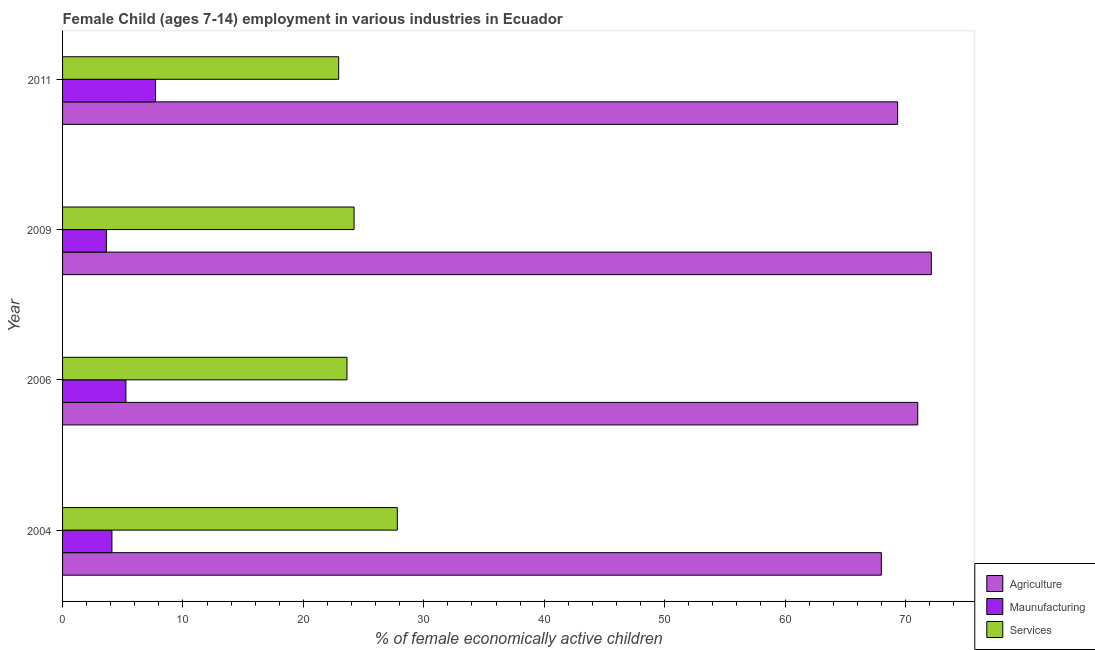How many groups of bars are there?
Provide a succinct answer. 4. Are the number of bars on each tick of the Y-axis equal?
Keep it short and to the point. Yes. How many bars are there on the 4th tick from the bottom?
Make the answer very short. 3. What is the label of the 1st group of bars from the top?
Provide a short and direct response. 2011. What is the percentage of economically active children in services in 2009?
Provide a short and direct response. 24.21. Across all years, what is the maximum percentage of economically active children in services?
Provide a short and direct response. 27.8. Across all years, what is the minimum percentage of economically active children in agriculture?
Keep it short and to the point. 68. What is the total percentage of economically active children in services in the graph?
Your answer should be compact. 98.56. What is the difference between the percentage of economically active children in manufacturing in 2006 and that in 2011?
Ensure brevity in your answer.  -2.46. What is the difference between the percentage of economically active children in services in 2006 and the percentage of economically active children in agriculture in 2011?
Offer a very short reply. -45.73. What is the average percentage of economically active children in agriculture per year?
Your response must be concise. 70.13. In the year 2006, what is the difference between the percentage of economically active children in agriculture and percentage of economically active children in manufacturing?
Provide a short and direct response. 65.76. What is the ratio of the percentage of economically active children in manufacturing in 2006 to that in 2009?
Ensure brevity in your answer.  1.45. Is the percentage of economically active children in services in 2006 less than that in 2011?
Offer a terse response. No. Is the difference between the percentage of economically active children in services in 2006 and 2011 greater than the difference between the percentage of economically active children in manufacturing in 2006 and 2011?
Your answer should be compact. Yes. What is the difference between the highest and the second highest percentage of economically active children in manufacturing?
Your response must be concise. 2.46. What is the difference between the highest and the lowest percentage of economically active children in manufacturing?
Provide a succinct answer. 4.08. Is the sum of the percentage of economically active children in services in 2006 and 2011 greater than the maximum percentage of economically active children in agriculture across all years?
Provide a short and direct response. No. What does the 1st bar from the top in 2004 represents?
Provide a succinct answer. Services. What does the 3rd bar from the bottom in 2004 represents?
Make the answer very short. Services. How many bars are there?
Give a very brief answer. 12. How many years are there in the graph?
Your answer should be very brief. 4. What is the difference between two consecutive major ticks on the X-axis?
Keep it short and to the point. 10. Does the graph contain any zero values?
Make the answer very short. No. Where does the legend appear in the graph?
Provide a short and direct response. Bottom right. What is the title of the graph?
Offer a very short reply. Female Child (ages 7-14) employment in various industries in Ecuador. What is the label or title of the X-axis?
Make the answer very short. % of female economically active children. What is the % of female economically active children of Agriculture in 2004?
Give a very brief answer. 68. What is the % of female economically active children of Maunufacturing in 2004?
Your answer should be very brief. 4.1. What is the % of female economically active children of Services in 2004?
Make the answer very short. 27.8. What is the % of female economically active children in Agriculture in 2006?
Ensure brevity in your answer.  71.02. What is the % of female economically active children in Maunufacturing in 2006?
Offer a terse response. 5.26. What is the % of female economically active children in Services in 2006?
Ensure brevity in your answer.  23.62. What is the % of female economically active children in Agriculture in 2009?
Provide a short and direct response. 72.15. What is the % of female economically active children of Maunufacturing in 2009?
Provide a short and direct response. 3.64. What is the % of female economically active children of Services in 2009?
Give a very brief answer. 24.21. What is the % of female economically active children of Agriculture in 2011?
Ensure brevity in your answer.  69.35. What is the % of female economically active children of Maunufacturing in 2011?
Offer a very short reply. 7.72. What is the % of female economically active children in Services in 2011?
Give a very brief answer. 22.93. Across all years, what is the maximum % of female economically active children in Agriculture?
Give a very brief answer. 72.15. Across all years, what is the maximum % of female economically active children of Maunufacturing?
Ensure brevity in your answer.  7.72. Across all years, what is the maximum % of female economically active children of Services?
Ensure brevity in your answer.  27.8. Across all years, what is the minimum % of female economically active children in Maunufacturing?
Give a very brief answer. 3.64. Across all years, what is the minimum % of female economically active children in Services?
Your answer should be compact. 22.93. What is the total % of female economically active children of Agriculture in the graph?
Keep it short and to the point. 280.52. What is the total % of female economically active children of Maunufacturing in the graph?
Provide a short and direct response. 20.72. What is the total % of female economically active children in Services in the graph?
Offer a very short reply. 98.56. What is the difference between the % of female economically active children in Agriculture in 2004 and that in 2006?
Offer a very short reply. -3.02. What is the difference between the % of female economically active children of Maunufacturing in 2004 and that in 2006?
Ensure brevity in your answer.  -1.16. What is the difference between the % of female economically active children of Services in 2004 and that in 2006?
Your answer should be very brief. 4.18. What is the difference between the % of female economically active children in Agriculture in 2004 and that in 2009?
Your response must be concise. -4.15. What is the difference between the % of female economically active children of Maunufacturing in 2004 and that in 2009?
Your response must be concise. 0.46. What is the difference between the % of female economically active children in Services in 2004 and that in 2009?
Offer a terse response. 3.59. What is the difference between the % of female economically active children of Agriculture in 2004 and that in 2011?
Keep it short and to the point. -1.35. What is the difference between the % of female economically active children in Maunufacturing in 2004 and that in 2011?
Offer a terse response. -3.62. What is the difference between the % of female economically active children in Services in 2004 and that in 2011?
Offer a very short reply. 4.87. What is the difference between the % of female economically active children in Agriculture in 2006 and that in 2009?
Your response must be concise. -1.13. What is the difference between the % of female economically active children in Maunufacturing in 2006 and that in 2009?
Offer a terse response. 1.62. What is the difference between the % of female economically active children of Services in 2006 and that in 2009?
Offer a terse response. -0.59. What is the difference between the % of female economically active children of Agriculture in 2006 and that in 2011?
Ensure brevity in your answer.  1.67. What is the difference between the % of female economically active children of Maunufacturing in 2006 and that in 2011?
Offer a very short reply. -2.46. What is the difference between the % of female economically active children in Services in 2006 and that in 2011?
Give a very brief answer. 0.69. What is the difference between the % of female economically active children of Agriculture in 2009 and that in 2011?
Your answer should be very brief. 2.8. What is the difference between the % of female economically active children in Maunufacturing in 2009 and that in 2011?
Give a very brief answer. -4.08. What is the difference between the % of female economically active children in Services in 2009 and that in 2011?
Your answer should be compact. 1.28. What is the difference between the % of female economically active children in Agriculture in 2004 and the % of female economically active children in Maunufacturing in 2006?
Keep it short and to the point. 62.74. What is the difference between the % of female economically active children in Agriculture in 2004 and the % of female economically active children in Services in 2006?
Offer a terse response. 44.38. What is the difference between the % of female economically active children of Maunufacturing in 2004 and the % of female economically active children of Services in 2006?
Offer a terse response. -19.52. What is the difference between the % of female economically active children of Agriculture in 2004 and the % of female economically active children of Maunufacturing in 2009?
Your answer should be very brief. 64.36. What is the difference between the % of female economically active children of Agriculture in 2004 and the % of female economically active children of Services in 2009?
Offer a very short reply. 43.79. What is the difference between the % of female economically active children in Maunufacturing in 2004 and the % of female economically active children in Services in 2009?
Offer a terse response. -20.11. What is the difference between the % of female economically active children in Agriculture in 2004 and the % of female economically active children in Maunufacturing in 2011?
Your answer should be very brief. 60.28. What is the difference between the % of female economically active children in Agriculture in 2004 and the % of female economically active children in Services in 2011?
Provide a succinct answer. 45.07. What is the difference between the % of female economically active children in Maunufacturing in 2004 and the % of female economically active children in Services in 2011?
Keep it short and to the point. -18.83. What is the difference between the % of female economically active children in Agriculture in 2006 and the % of female economically active children in Maunufacturing in 2009?
Ensure brevity in your answer.  67.38. What is the difference between the % of female economically active children of Agriculture in 2006 and the % of female economically active children of Services in 2009?
Your response must be concise. 46.81. What is the difference between the % of female economically active children of Maunufacturing in 2006 and the % of female economically active children of Services in 2009?
Provide a short and direct response. -18.95. What is the difference between the % of female economically active children of Agriculture in 2006 and the % of female economically active children of Maunufacturing in 2011?
Your answer should be very brief. 63.3. What is the difference between the % of female economically active children of Agriculture in 2006 and the % of female economically active children of Services in 2011?
Keep it short and to the point. 48.09. What is the difference between the % of female economically active children of Maunufacturing in 2006 and the % of female economically active children of Services in 2011?
Provide a succinct answer. -17.67. What is the difference between the % of female economically active children of Agriculture in 2009 and the % of female economically active children of Maunufacturing in 2011?
Your response must be concise. 64.43. What is the difference between the % of female economically active children in Agriculture in 2009 and the % of female economically active children in Services in 2011?
Provide a succinct answer. 49.22. What is the difference between the % of female economically active children of Maunufacturing in 2009 and the % of female economically active children of Services in 2011?
Ensure brevity in your answer.  -19.29. What is the average % of female economically active children in Agriculture per year?
Ensure brevity in your answer.  70.13. What is the average % of female economically active children in Maunufacturing per year?
Offer a terse response. 5.18. What is the average % of female economically active children in Services per year?
Give a very brief answer. 24.64. In the year 2004, what is the difference between the % of female economically active children of Agriculture and % of female economically active children of Maunufacturing?
Keep it short and to the point. 63.9. In the year 2004, what is the difference between the % of female economically active children in Agriculture and % of female economically active children in Services?
Make the answer very short. 40.2. In the year 2004, what is the difference between the % of female economically active children in Maunufacturing and % of female economically active children in Services?
Provide a short and direct response. -23.7. In the year 2006, what is the difference between the % of female economically active children in Agriculture and % of female economically active children in Maunufacturing?
Ensure brevity in your answer.  65.76. In the year 2006, what is the difference between the % of female economically active children in Agriculture and % of female economically active children in Services?
Give a very brief answer. 47.4. In the year 2006, what is the difference between the % of female economically active children of Maunufacturing and % of female economically active children of Services?
Keep it short and to the point. -18.36. In the year 2009, what is the difference between the % of female economically active children of Agriculture and % of female economically active children of Maunufacturing?
Your answer should be very brief. 68.51. In the year 2009, what is the difference between the % of female economically active children in Agriculture and % of female economically active children in Services?
Make the answer very short. 47.94. In the year 2009, what is the difference between the % of female economically active children of Maunufacturing and % of female economically active children of Services?
Keep it short and to the point. -20.57. In the year 2011, what is the difference between the % of female economically active children in Agriculture and % of female economically active children in Maunufacturing?
Keep it short and to the point. 61.63. In the year 2011, what is the difference between the % of female economically active children in Agriculture and % of female economically active children in Services?
Your answer should be very brief. 46.42. In the year 2011, what is the difference between the % of female economically active children of Maunufacturing and % of female economically active children of Services?
Your answer should be compact. -15.21. What is the ratio of the % of female economically active children in Agriculture in 2004 to that in 2006?
Your answer should be very brief. 0.96. What is the ratio of the % of female economically active children of Maunufacturing in 2004 to that in 2006?
Provide a succinct answer. 0.78. What is the ratio of the % of female economically active children of Services in 2004 to that in 2006?
Your answer should be compact. 1.18. What is the ratio of the % of female economically active children of Agriculture in 2004 to that in 2009?
Provide a short and direct response. 0.94. What is the ratio of the % of female economically active children in Maunufacturing in 2004 to that in 2009?
Make the answer very short. 1.13. What is the ratio of the % of female economically active children of Services in 2004 to that in 2009?
Give a very brief answer. 1.15. What is the ratio of the % of female economically active children in Agriculture in 2004 to that in 2011?
Ensure brevity in your answer.  0.98. What is the ratio of the % of female economically active children in Maunufacturing in 2004 to that in 2011?
Ensure brevity in your answer.  0.53. What is the ratio of the % of female economically active children in Services in 2004 to that in 2011?
Your response must be concise. 1.21. What is the ratio of the % of female economically active children in Agriculture in 2006 to that in 2009?
Provide a succinct answer. 0.98. What is the ratio of the % of female economically active children in Maunufacturing in 2006 to that in 2009?
Make the answer very short. 1.45. What is the ratio of the % of female economically active children of Services in 2006 to that in 2009?
Your response must be concise. 0.98. What is the ratio of the % of female economically active children of Agriculture in 2006 to that in 2011?
Make the answer very short. 1.02. What is the ratio of the % of female economically active children in Maunufacturing in 2006 to that in 2011?
Your answer should be compact. 0.68. What is the ratio of the % of female economically active children of Services in 2006 to that in 2011?
Your answer should be compact. 1.03. What is the ratio of the % of female economically active children in Agriculture in 2009 to that in 2011?
Your response must be concise. 1.04. What is the ratio of the % of female economically active children in Maunufacturing in 2009 to that in 2011?
Ensure brevity in your answer.  0.47. What is the ratio of the % of female economically active children in Services in 2009 to that in 2011?
Provide a short and direct response. 1.06. What is the difference between the highest and the second highest % of female economically active children in Agriculture?
Your answer should be compact. 1.13. What is the difference between the highest and the second highest % of female economically active children of Maunufacturing?
Your response must be concise. 2.46. What is the difference between the highest and the second highest % of female economically active children of Services?
Give a very brief answer. 3.59. What is the difference between the highest and the lowest % of female economically active children of Agriculture?
Provide a succinct answer. 4.15. What is the difference between the highest and the lowest % of female economically active children of Maunufacturing?
Offer a terse response. 4.08. What is the difference between the highest and the lowest % of female economically active children of Services?
Your answer should be compact. 4.87. 